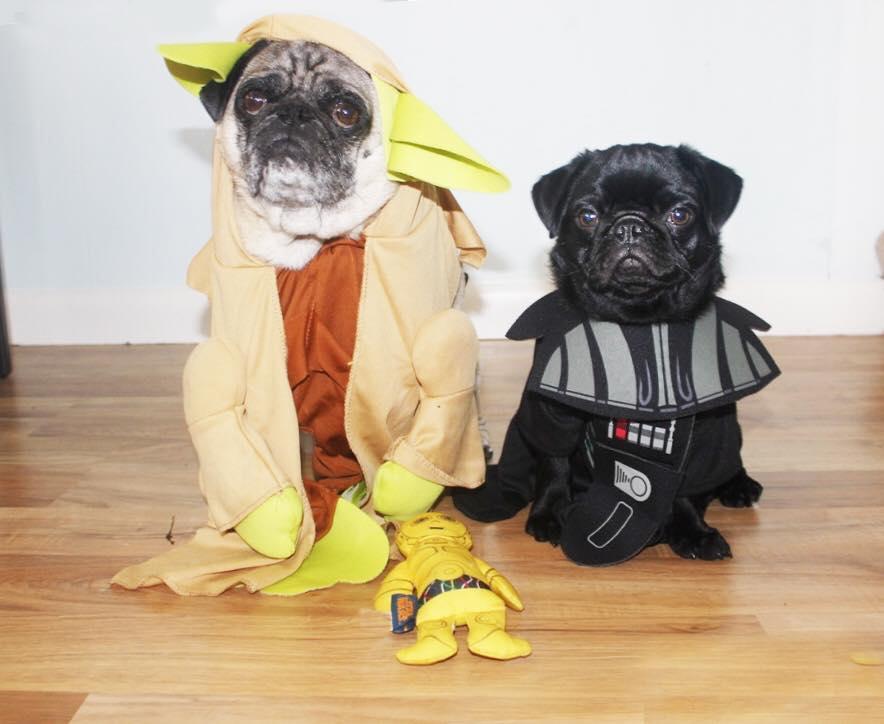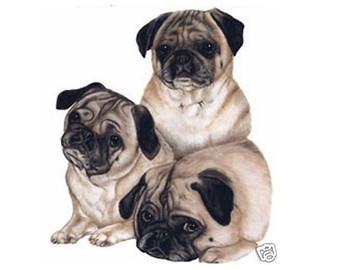The first image is the image on the left, the second image is the image on the right. Considering the images on both sides, is "All dogs shown are buff-beige pugs with closed mouths, and one pug is pictured with a cake image by its face." valid? Answer yes or no. No. The first image is the image on the left, the second image is the image on the right. For the images displayed, is the sentence "The right image contains three pug dogs." factually correct? Answer yes or no. Yes. 